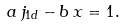<formula> <loc_0><loc_0><loc_500><loc_500>a \, j _ { 1 d } - b \, x = 1 .</formula> 